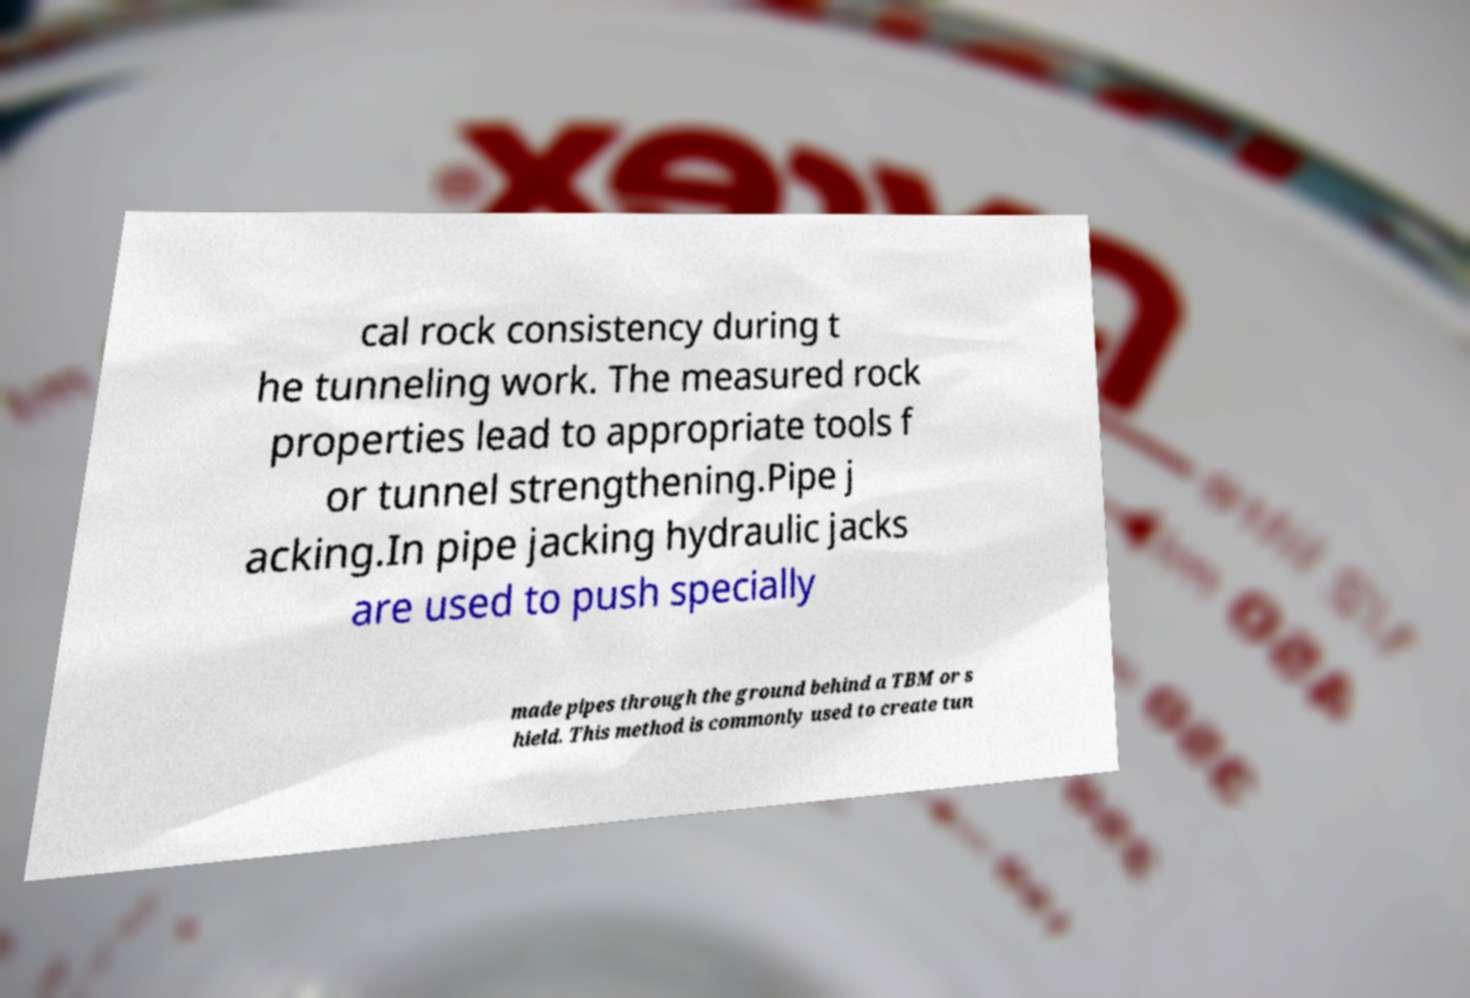Can you accurately transcribe the text from the provided image for me? cal rock consistency during t he tunneling work. The measured rock properties lead to appropriate tools f or tunnel strengthening.Pipe j acking.In pipe jacking hydraulic jacks are used to push specially made pipes through the ground behind a TBM or s hield. This method is commonly used to create tun 